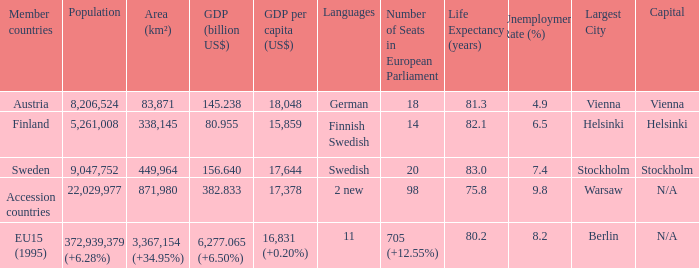Name the population for 11 languages 372,939,379 (+6.28%). 